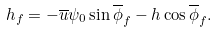<formula> <loc_0><loc_0><loc_500><loc_500>h _ { f } = - \overline { u } \psi _ { 0 } \sin \overline { \phi } _ { f } - h \cos \overline { \phi } _ { f } .</formula> 